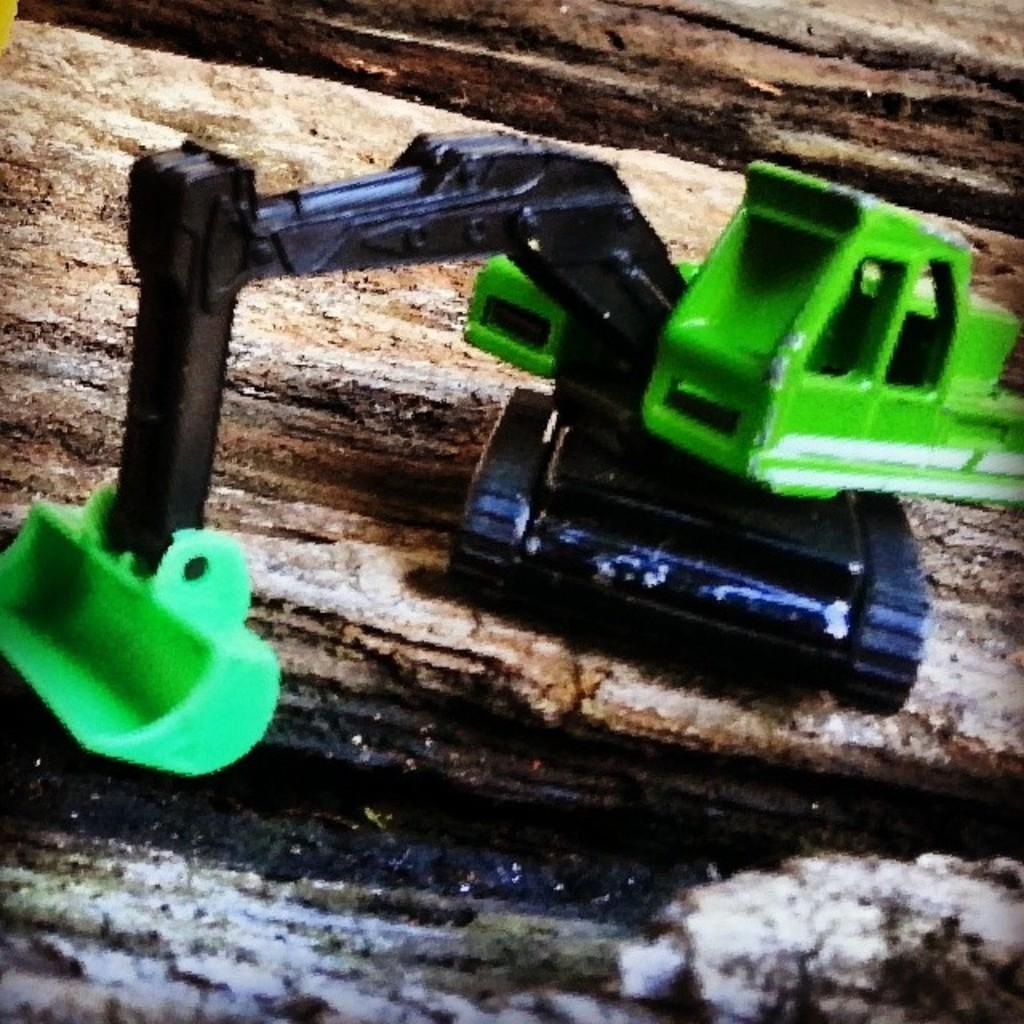Can you describe this image briefly? There is a jcb toy which is green and black in color is placed on an object. 